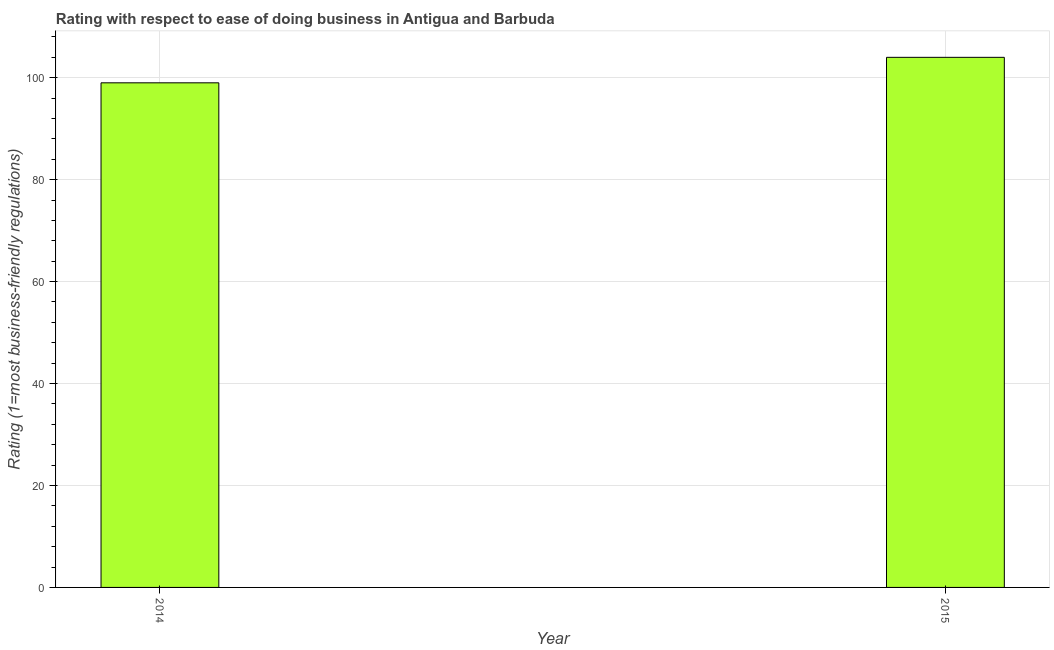Does the graph contain any zero values?
Ensure brevity in your answer.  No. What is the title of the graph?
Ensure brevity in your answer.  Rating with respect to ease of doing business in Antigua and Barbuda. What is the label or title of the Y-axis?
Keep it short and to the point. Rating (1=most business-friendly regulations). Across all years, what is the maximum ease of doing business index?
Give a very brief answer. 104. Across all years, what is the minimum ease of doing business index?
Your answer should be very brief. 99. In which year was the ease of doing business index maximum?
Make the answer very short. 2015. In which year was the ease of doing business index minimum?
Ensure brevity in your answer.  2014. What is the sum of the ease of doing business index?
Give a very brief answer. 203. What is the average ease of doing business index per year?
Your answer should be very brief. 101. What is the median ease of doing business index?
Give a very brief answer. 101.5. In how many years, is the ease of doing business index greater than 44 ?
Your answer should be compact. 2. Do a majority of the years between 2015 and 2014 (inclusive) have ease of doing business index greater than 92 ?
Make the answer very short. No. What is the ratio of the ease of doing business index in 2014 to that in 2015?
Your answer should be very brief. 0.95. Is the ease of doing business index in 2014 less than that in 2015?
Offer a very short reply. Yes. In how many years, is the ease of doing business index greater than the average ease of doing business index taken over all years?
Make the answer very short. 1. How many bars are there?
Provide a succinct answer. 2. Are all the bars in the graph horizontal?
Provide a succinct answer. No. What is the Rating (1=most business-friendly regulations) of 2015?
Keep it short and to the point. 104. 